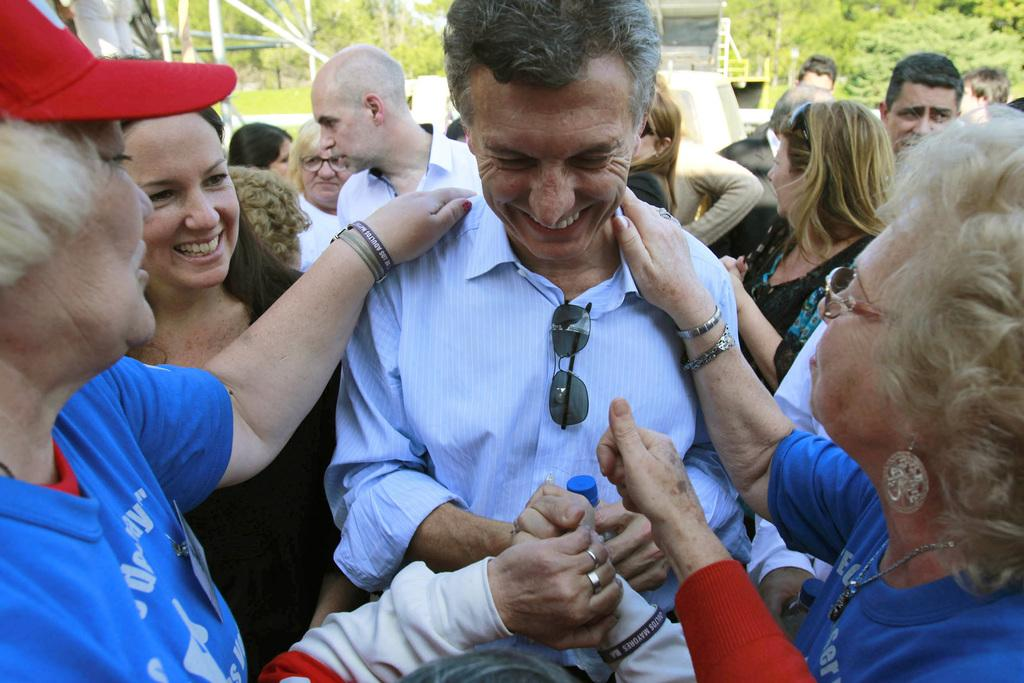What is happening in the middle of the image? There are people standing in the middle of the image. How are the people in the image feeling? The people are smiling in the image. What can be seen in the background behind the people? There are trees behind the people. What other objects are visible in the image? There are poles visible in the image. What is the source of fear in the image? There is no indication of fear in the image, as the people are smiling. What season is depicted in the image? The provided facts do not mention any specific season, so it cannot be determined from the image. 